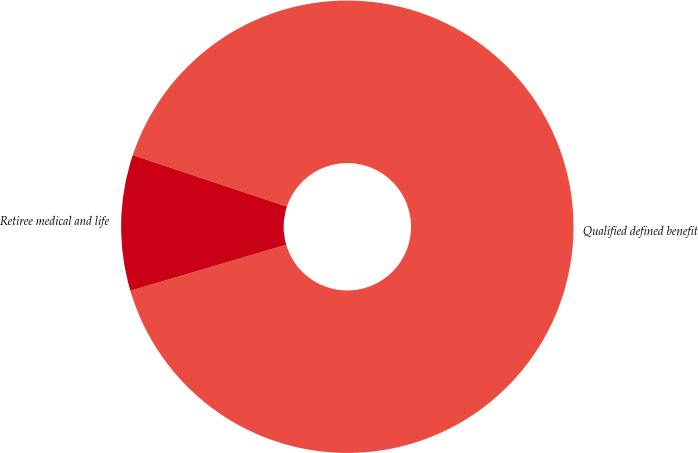Convert chart to OTSL. <chart><loc_0><loc_0><loc_500><loc_500><pie_chart><fcel>Qualified defined benefit<fcel>Retiree medical and life<nl><fcel>90.31%<fcel>9.69%<nl></chart> 